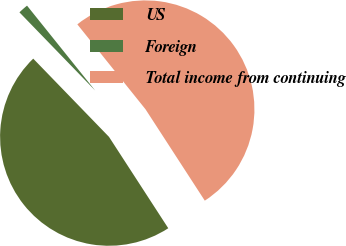Convert chart to OTSL. <chart><loc_0><loc_0><loc_500><loc_500><pie_chart><fcel>US<fcel>Foreign<fcel>Total income from continuing<nl><fcel>46.92%<fcel>1.48%<fcel>51.61%<nl></chart> 